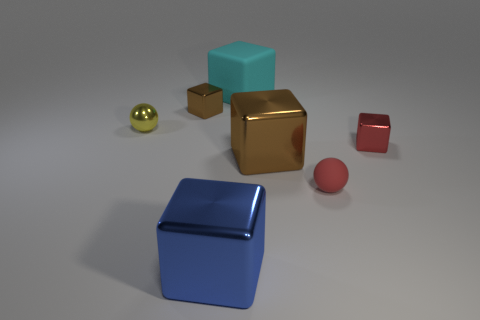There is a cube that is in front of the red matte sphere; what is its size?
Provide a succinct answer. Large. What is the material of the brown cube that is to the left of the big object in front of the tiny red rubber object?
Make the answer very short. Metal. There is a small metal object that is on the right side of the big shiny cube in front of the matte ball; what number of blue metal blocks are behind it?
Provide a short and direct response. 0. Does the big cyan object that is right of the blue block have the same material as the brown thing behind the large brown cube?
Make the answer very short. No. There is another object that is the same color as the tiny rubber object; what is its material?
Make the answer very short. Metal. How many other big blue metallic objects are the same shape as the blue object?
Give a very brief answer. 0. Is the number of tiny things that are behind the matte cube greater than the number of brown objects?
Your answer should be very brief. No. The small red thing behind the brown thing that is in front of the small shiny cube in front of the tiny brown cube is what shape?
Offer a very short reply. Cube. Is the shape of the large shiny object behind the blue metallic thing the same as the small metallic object on the right side of the cyan matte cube?
Keep it short and to the point. Yes. Is there any other thing that is the same size as the blue metal cube?
Offer a terse response. Yes. 